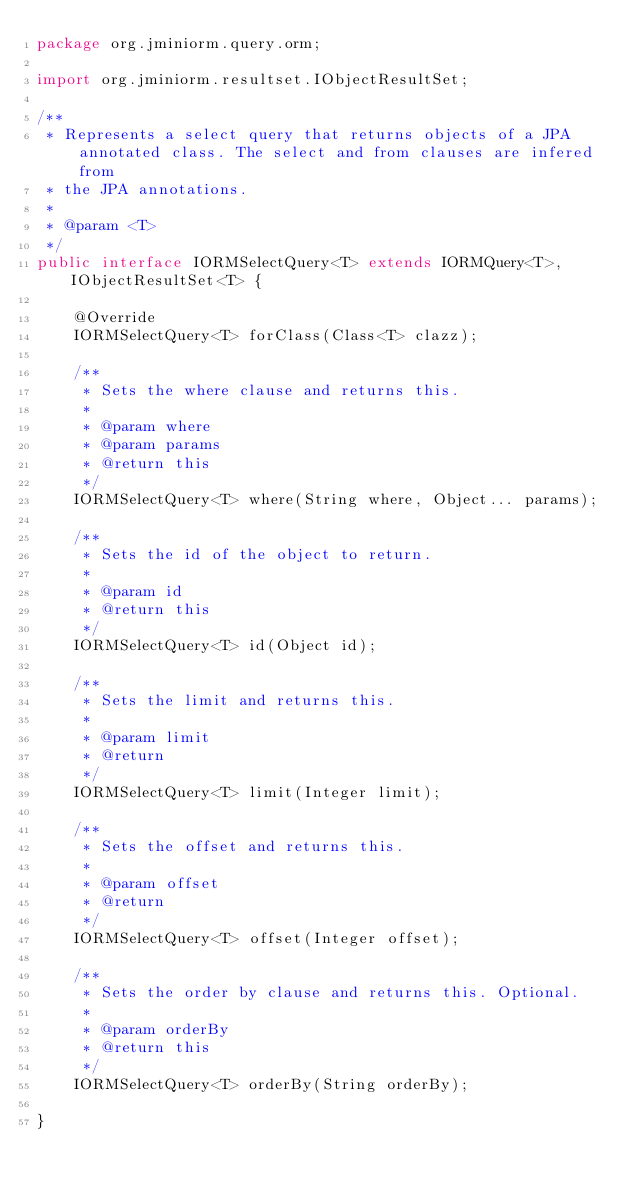Convert code to text. <code><loc_0><loc_0><loc_500><loc_500><_Java_>package org.jminiorm.query.orm;

import org.jminiorm.resultset.IObjectResultSet;

/**
 * Represents a select query that returns objects of a JPA annotated class. The select and from clauses are infered from
 * the JPA annotations.
 *
 * @param <T>
 */
public interface IORMSelectQuery<T> extends IORMQuery<T>, IObjectResultSet<T> {

    @Override
    IORMSelectQuery<T> forClass(Class<T> clazz);

    /**
     * Sets the where clause and returns this.
     *
     * @param where
     * @param params
     * @return this
     */
    IORMSelectQuery<T> where(String where, Object... params);

    /**
     * Sets the id of the object to return.
     *
     * @param id
     * @return this
     */
    IORMSelectQuery<T> id(Object id);

    /**
     * Sets the limit and returns this.
     *
     * @param limit
     * @return
     */
    IORMSelectQuery<T> limit(Integer limit);

    /**
     * Sets the offset and returns this.
     *
     * @param offset
     * @return
     */
    IORMSelectQuery<T> offset(Integer offset);

    /**
     * Sets the order by clause and returns this. Optional.
     *
     * @param orderBy
     * @return this
     */
    IORMSelectQuery<T> orderBy(String orderBy);

}
</code> 